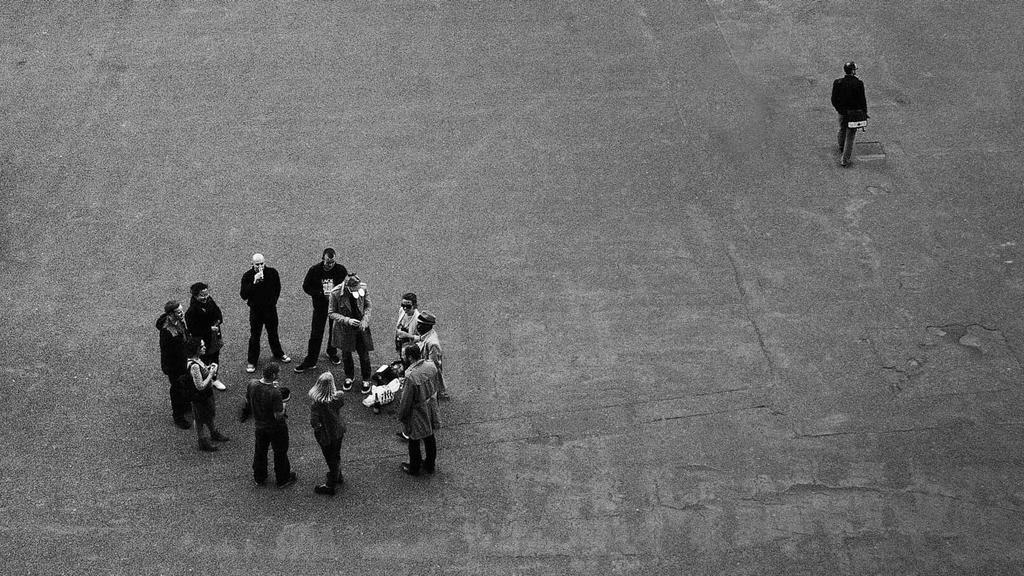How many people are in the image? There are multiple persons in the image. How are the persons arranged in the image? The persons are standing in a circular formation. Is there anyone else in the image besides the persons in the circular formation? Yes, there is another person standing in the right top corner of the image. What subject is the person in the right top corner teaching in the image? There is no indication in the image that the person in the right top corner is teaching a subject. 